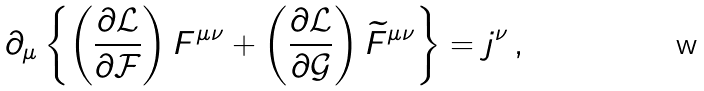Convert formula to latex. <formula><loc_0><loc_0><loc_500><loc_500>\partial _ { \mu } \left \{ \left ( \frac { \partial \mathcal { L } } { \partial \mathcal { F } } \right ) F ^ { \mu \nu } + \left ( \frac { \partial \mathcal { L } } { \partial \mathcal { G } } \right ) \widetilde { F } ^ { \mu \nu } \right \} = j ^ { \nu } \, ,</formula> 